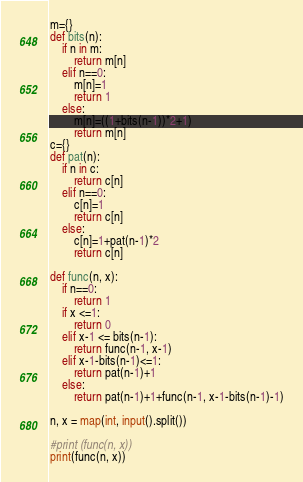<code> <loc_0><loc_0><loc_500><loc_500><_Python_>
m={}
def bits(n):
    if n in m:
        return m[n]
    elif n==0:
        m[n]=1
        return 1
    else:
        m[n]=((1+bits(n-1))*2+1)
        return m[n]
c={}
def pat(n):
    if n in c:
        return c[n]
    elif n==0:
        c[n]=1
        return c[n]
    else:
        c[n]=1+pat(n-1)*2
        return c[n]

def func(n, x):
    if n==0:
        return 1
    if x <=1:
        return 0
    elif x-1 <= bits(n-1):
        return func(n-1, x-1)
    elif x-1-bits(n-1)<=1:
        return pat(n-1)+1
    else:
        return pat(n-1)+1+func(n-1, x-1-bits(n-1)-1)

n, x = map(int, input().split())

#print (func(n, x))
print(func(n, x))
</code> 